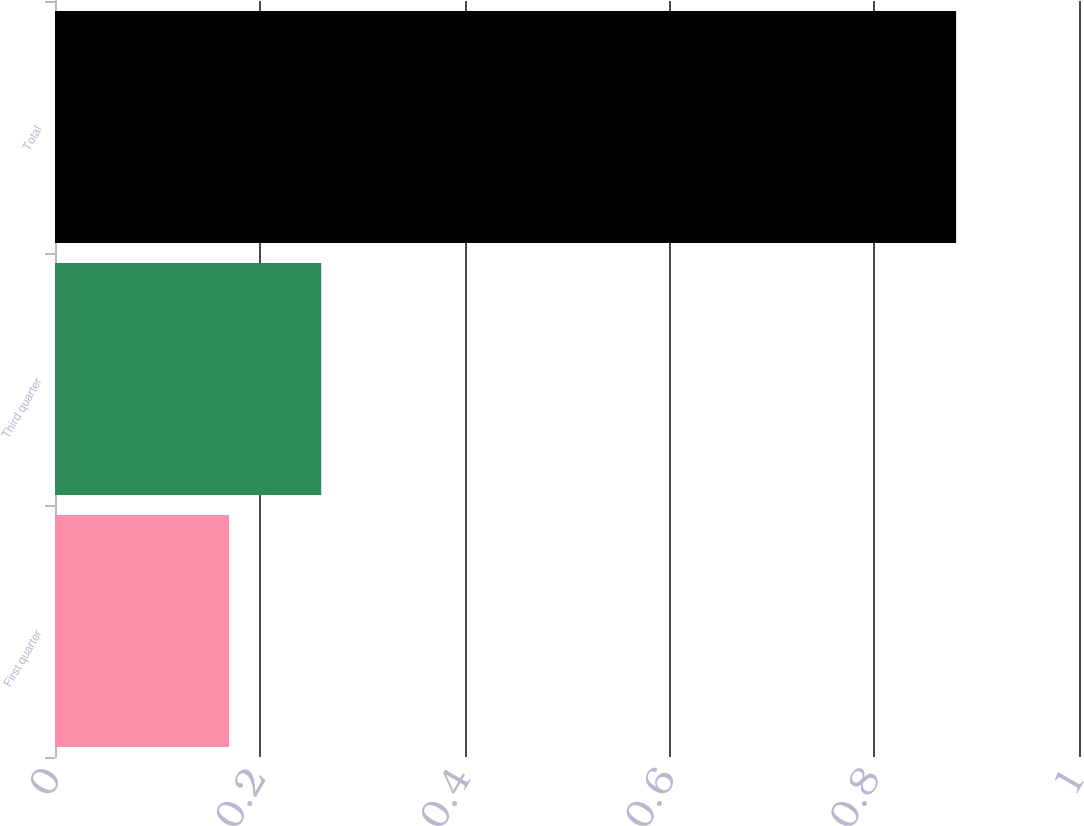<chart> <loc_0><loc_0><loc_500><loc_500><bar_chart><fcel>First quarter<fcel>Third quarter<fcel>Total<nl><fcel>0.17<fcel>0.26<fcel>0.88<nl></chart> 